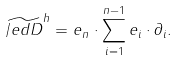Convert formula to latex. <formula><loc_0><loc_0><loc_500><loc_500>\widetilde { \slash e d { D } } ^ { h } = e _ { n } \cdot \sum _ { i = 1 } ^ { n - 1 } e _ { i } \cdot \partial _ { i } .</formula> 